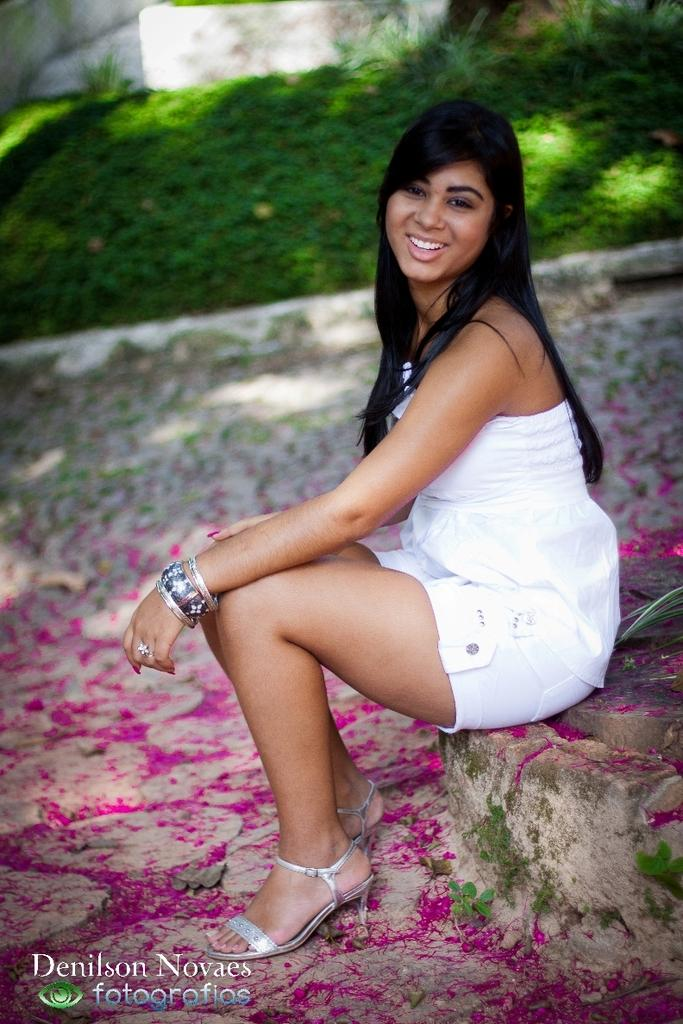What is the lady in the image doing? The lady is sitting on a stone wall in the image. What can be seen in the background of the image? There is a wall in the background of the image. How would you describe the background of the image? The background is blurry. What is present on the ground in the image? There are pink-colored things on the ground in the image. What type of bridge can be seen in the image? There is no bridge present in the image. 